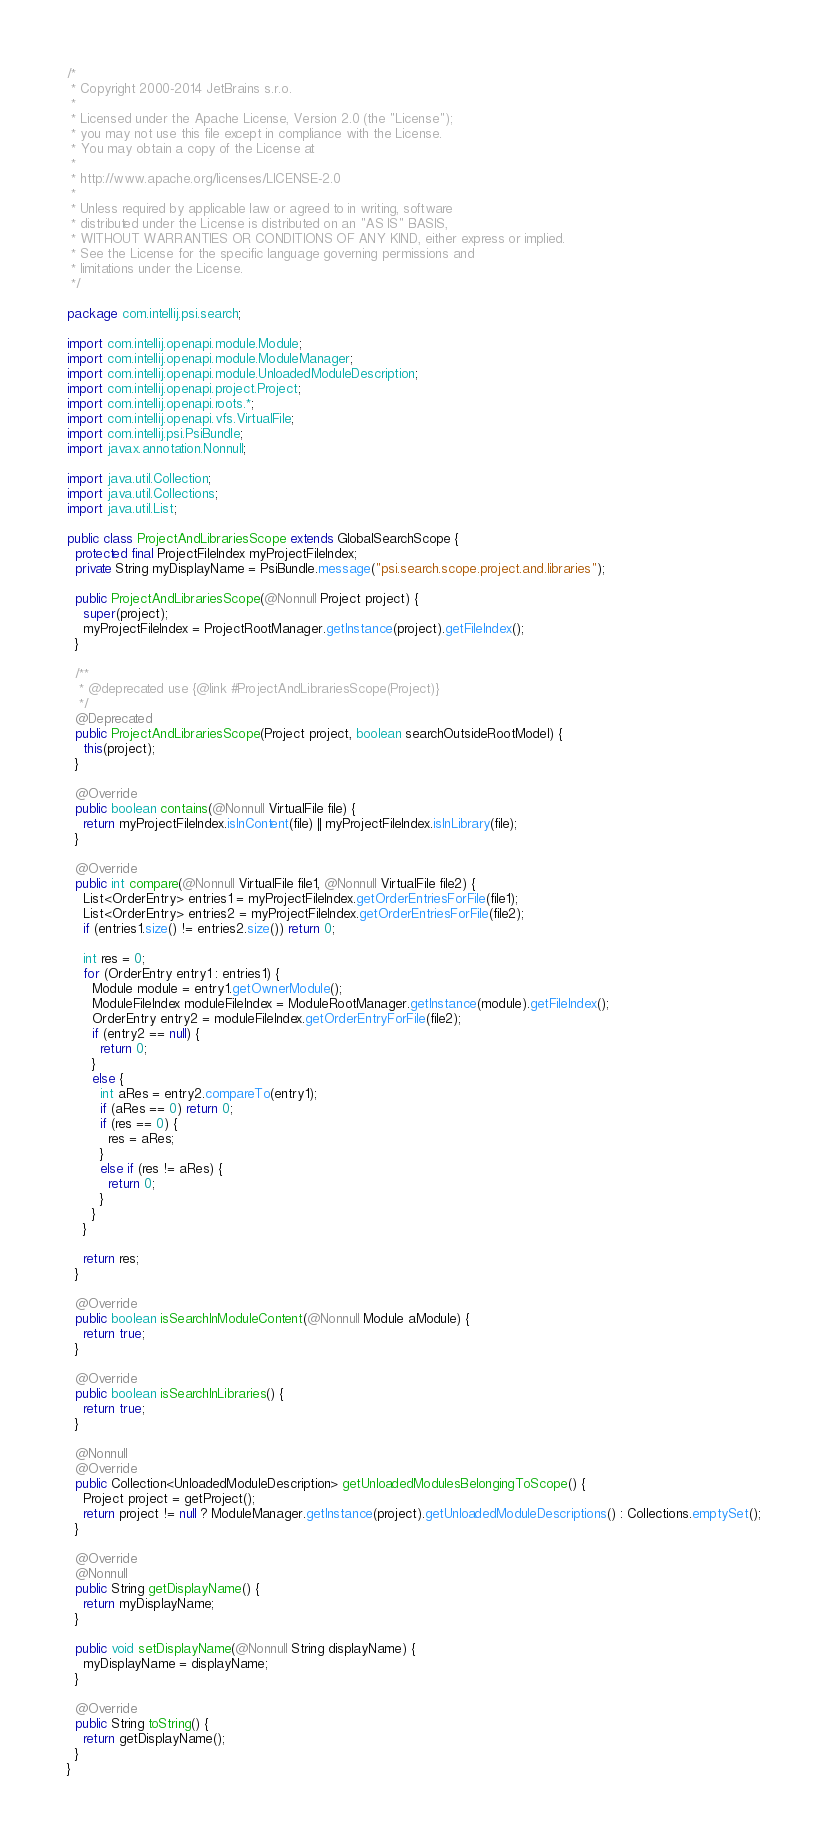<code> <loc_0><loc_0><loc_500><loc_500><_Java_>/*
 * Copyright 2000-2014 JetBrains s.r.o.
 *
 * Licensed under the Apache License, Version 2.0 (the "License");
 * you may not use this file except in compliance with the License.
 * You may obtain a copy of the License at
 *
 * http://www.apache.org/licenses/LICENSE-2.0
 *
 * Unless required by applicable law or agreed to in writing, software
 * distributed under the License is distributed on an "AS IS" BASIS,
 * WITHOUT WARRANTIES OR CONDITIONS OF ANY KIND, either express or implied.
 * See the License for the specific language governing permissions and
 * limitations under the License.
 */

package com.intellij.psi.search;

import com.intellij.openapi.module.Module;
import com.intellij.openapi.module.ModuleManager;
import com.intellij.openapi.module.UnloadedModuleDescription;
import com.intellij.openapi.project.Project;
import com.intellij.openapi.roots.*;
import com.intellij.openapi.vfs.VirtualFile;
import com.intellij.psi.PsiBundle;
import javax.annotation.Nonnull;

import java.util.Collection;
import java.util.Collections;
import java.util.List;

public class ProjectAndLibrariesScope extends GlobalSearchScope {
  protected final ProjectFileIndex myProjectFileIndex;
  private String myDisplayName = PsiBundle.message("psi.search.scope.project.and.libraries");

  public ProjectAndLibrariesScope(@Nonnull Project project) {
    super(project);
    myProjectFileIndex = ProjectRootManager.getInstance(project).getFileIndex();
  }

  /**
   * @deprecated use {@link #ProjectAndLibrariesScope(Project)}
   */
  @Deprecated
  public ProjectAndLibrariesScope(Project project, boolean searchOutsideRootModel) {
    this(project);
  }

  @Override
  public boolean contains(@Nonnull VirtualFile file) {
    return myProjectFileIndex.isInContent(file) || myProjectFileIndex.isInLibrary(file);
  }

  @Override
  public int compare(@Nonnull VirtualFile file1, @Nonnull VirtualFile file2) {
    List<OrderEntry> entries1 = myProjectFileIndex.getOrderEntriesForFile(file1);
    List<OrderEntry> entries2 = myProjectFileIndex.getOrderEntriesForFile(file2);
    if (entries1.size() != entries2.size()) return 0;

    int res = 0;
    for (OrderEntry entry1 : entries1) {
      Module module = entry1.getOwnerModule();
      ModuleFileIndex moduleFileIndex = ModuleRootManager.getInstance(module).getFileIndex();
      OrderEntry entry2 = moduleFileIndex.getOrderEntryForFile(file2);
      if (entry2 == null) {
        return 0;
      }
      else {
        int aRes = entry2.compareTo(entry1);
        if (aRes == 0) return 0;
        if (res == 0) {
          res = aRes;
        }
        else if (res != aRes) {
          return 0;
        }
      }
    }

    return res;
  }

  @Override
  public boolean isSearchInModuleContent(@Nonnull Module aModule) {
    return true;
  }

  @Override
  public boolean isSearchInLibraries() {
    return true;
  }

  @Nonnull
  @Override
  public Collection<UnloadedModuleDescription> getUnloadedModulesBelongingToScope() {
    Project project = getProject();
    return project != null ? ModuleManager.getInstance(project).getUnloadedModuleDescriptions() : Collections.emptySet();
  }

  @Override
  @Nonnull
  public String getDisplayName() {
    return myDisplayName;
  }

  public void setDisplayName(@Nonnull String displayName) {
    myDisplayName = displayName;
  }

  @Override
  public String toString() {
    return getDisplayName();
  }
}</code> 